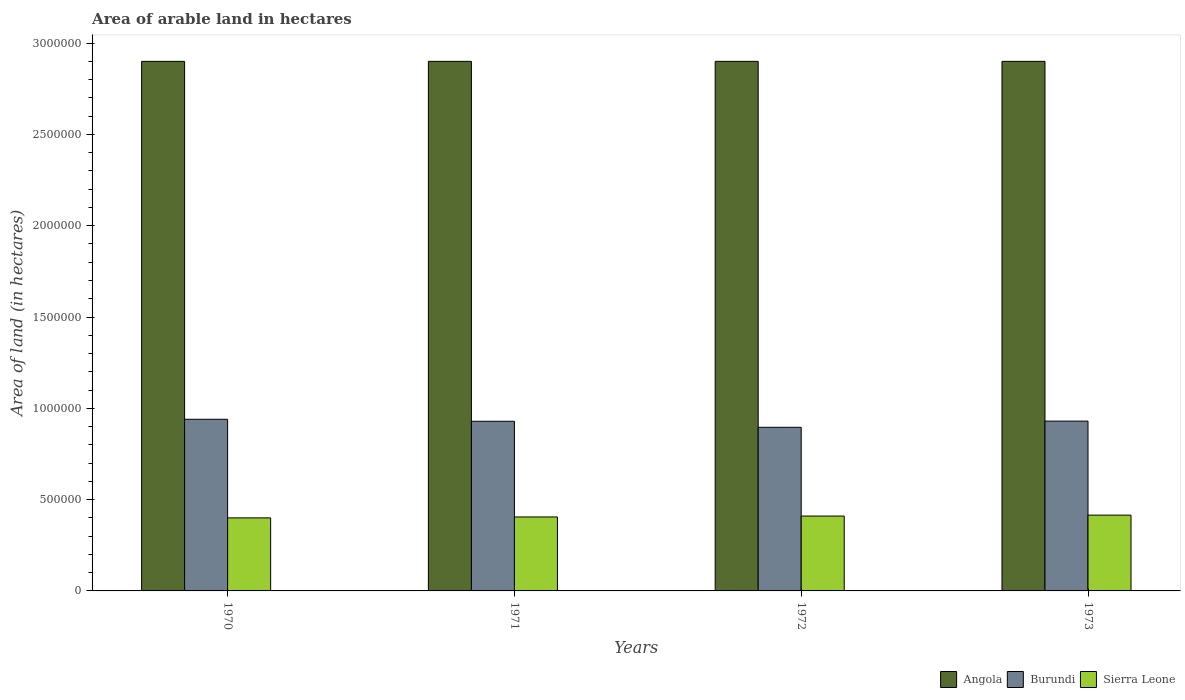How many different coloured bars are there?
Your response must be concise. 3. How many groups of bars are there?
Your answer should be very brief. 4. Are the number of bars per tick equal to the number of legend labels?
Make the answer very short. Yes. How many bars are there on the 3rd tick from the right?
Provide a succinct answer. 3. In how many cases, is the number of bars for a given year not equal to the number of legend labels?
Ensure brevity in your answer.  0. What is the total arable land in Sierra Leone in 1973?
Keep it short and to the point. 4.15e+05. Across all years, what is the maximum total arable land in Angola?
Offer a terse response. 2.90e+06. Across all years, what is the minimum total arable land in Angola?
Ensure brevity in your answer.  2.90e+06. In which year was the total arable land in Burundi maximum?
Provide a succinct answer. 1970. In which year was the total arable land in Angola minimum?
Offer a terse response. 1970. What is the total total arable land in Angola in the graph?
Ensure brevity in your answer.  1.16e+07. What is the difference between the total arable land in Angola in 1972 and that in 1973?
Provide a short and direct response. 0. What is the difference between the total arable land in Angola in 1970 and the total arable land in Burundi in 1972?
Your answer should be compact. 2.00e+06. What is the average total arable land in Angola per year?
Keep it short and to the point. 2.90e+06. In the year 1971, what is the difference between the total arable land in Burundi and total arable land in Angola?
Ensure brevity in your answer.  -1.97e+06. In how many years, is the total arable land in Burundi greater than 2200000 hectares?
Make the answer very short. 0. Is the total arable land in Burundi in 1971 less than that in 1973?
Offer a very short reply. Yes. What is the difference between the highest and the second highest total arable land in Angola?
Offer a terse response. 0. What is the difference between the highest and the lowest total arable land in Sierra Leone?
Keep it short and to the point. 1.50e+04. In how many years, is the total arable land in Burundi greater than the average total arable land in Burundi taken over all years?
Your answer should be very brief. 3. What does the 3rd bar from the left in 1972 represents?
Ensure brevity in your answer.  Sierra Leone. What does the 2nd bar from the right in 1970 represents?
Keep it short and to the point. Burundi. What is the difference between two consecutive major ticks on the Y-axis?
Make the answer very short. 5.00e+05. Where does the legend appear in the graph?
Your answer should be very brief. Bottom right. How many legend labels are there?
Your response must be concise. 3. How are the legend labels stacked?
Offer a terse response. Horizontal. What is the title of the graph?
Make the answer very short. Area of arable land in hectares. Does "Other small states" appear as one of the legend labels in the graph?
Keep it short and to the point. No. What is the label or title of the Y-axis?
Provide a succinct answer. Area of land (in hectares). What is the Area of land (in hectares) of Angola in 1970?
Ensure brevity in your answer.  2.90e+06. What is the Area of land (in hectares) of Burundi in 1970?
Keep it short and to the point. 9.40e+05. What is the Area of land (in hectares) of Angola in 1971?
Give a very brief answer. 2.90e+06. What is the Area of land (in hectares) in Burundi in 1971?
Keep it short and to the point. 9.29e+05. What is the Area of land (in hectares) of Sierra Leone in 1971?
Offer a very short reply. 4.05e+05. What is the Area of land (in hectares) in Angola in 1972?
Give a very brief answer. 2.90e+06. What is the Area of land (in hectares) in Burundi in 1972?
Your answer should be very brief. 8.96e+05. What is the Area of land (in hectares) of Sierra Leone in 1972?
Offer a terse response. 4.10e+05. What is the Area of land (in hectares) in Angola in 1973?
Offer a terse response. 2.90e+06. What is the Area of land (in hectares) of Burundi in 1973?
Your answer should be very brief. 9.30e+05. What is the Area of land (in hectares) of Sierra Leone in 1973?
Your answer should be very brief. 4.15e+05. Across all years, what is the maximum Area of land (in hectares) of Angola?
Ensure brevity in your answer.  2.90e+06. Across all years, what is the maximum Area of land (in hectares) of Burundi?
Provide a short and direct response. 9.40e+05. Across all years, what is the maximum Area of land (in hectares) of Sierra Leone?
Ensure brevity in your answer.  4.15e+05. Across all years, what is the minimum Area of land (in hectares) in Angola?
Provide a short and direct response. 2.90e+06. Across all years, what is the minimum Area of land (in hectares) of Burundi?
Ensure brevity in your answer.  8.96e+05. Across all years, what is the minimum Area of land (in hectares) in Sierra Leone?
Your answer should be compact. 4.00e+05. What is the total Area of land (in hectares) in Angola in the graph?
Give a very brief answer. 1.16e+07. What is the total Area of land (in hectares) in Burundi in the graph?
Ensure brevity in your answer.  3.70e+06. What is the total Area of land (in hectares) of Sierra Leone in the graph?
Provide a succinct answer. 1.63e+06. What is the difference between the Area of land (in hectares) of Angola in 1970 and that in 1971?
Your answer should be compact. 0. What is the difference between the Area of land (in hectares) of Burundi in 1970 and that in 1971?
Provide a short and direct response. 1.10e+04. What is the difference between the Area of land (in hectares) in Sierra Leone in 1970 and that in 1971?
Keep it short and to the point. -5000. What is the difference between the Area of land (in hectares) in Burundi in 1970 and that in 1972?
Ensure brevity in your answer.  4.40e+04. What is the difference between the Area of land (in hectares) of Angola in 1970 and that in 1973?
Ensure brevity in your answer.  0. What is the difference between the Area of land (in hectares) of Sierra Leone in 1970 and that in 1973?
Provide a short and direct response. -1.50e+04. What is the difference between the Area of land (in hectares) in Angola in 1971 and that in 1972?
Keep it short and to the point. 0. What is the difference between the Area of land (in hectares) of Burundi in 1971 and that in 1972?
Keep it short and to the point. 3.30e+04. What is the difference between the Area of land (in hectares) in Sierra Leone in 1971 and that in 1972?
Make the answer very short. -5000. What is the difference between the Area of land (in hectares) in Burundi in 1971 and that in 1973?
Provide a short and direct response. -1000. What is the difference between the Area of land (in hectares) of Sierra Leone in 1971 and that in 1973?
Offer a very short reply. -10000. What is the difference between the Area of land (in hectares) in Angola in 1972 and that in 1973?
Offer a terse response. 0. What is the difference between the Area of land (in hectares) of Burundi in 1972 and that in 1973?
Your answer should be very brief. -3.40e+04. What is the difference between the Area of land (in hectares) in Sierra Leone in 1972 and that in 1973?
Offer a very short reply. -5000. What is the difference between the Area of land (in hectares) in Angola in 1970 and the Area of land (in hectares) in Burundi in 1971?
Ensure brevity in your answer.  1.97e+06. What is the difference between the Area of land (in hectares) of Angola in 1970 and the Area of land (in hectares) of Sierra Leone in 1971?
Ensure brevity in your answer.  2.50e+06. What is the difference between the Area of land (in hectares) in Burundi in 1970 and the Area of land (in hectares) in Sierra Leone in 1971?
Offer a terse response. 5.35e+05. What is the difference between the Area of land (in hectares) in Angola in 1970 and the Area of land (in hectares) in Burundi in 1972?
Make the answer very short. 2.00e+06. What is the difference between the Area of land (in hectares) of Angola in 1970 and the Area of land (in hectares) of Sierra Leone in 1972?
Give a very brief answer. 2.49e+06. What is the difference between the Area of land (in hectares) in Burundi in 1970 and the Area of land (in hectares) in Sierra Leone in 1972?
Keep it short and to the point. 5.30e+05. What is the difference between the Area of land (in hectares) of Angola in 1970 and the Area of land (in hectares) of Burundi in 1973?
Offer a terse response. 1.97e+06. What is the difference between the Area of land (in hectares) in Angola in 1970 and the Area of land (in hectares) in Sierra Leone in 1973?
Your answer should be compact. 2.48e+06. What is the difference between the Area of land (in hectares) of Burundi in 1970 and the Area of land (in hectares) of Sierra Leone in 1973?
Provide a short and direct response. 5.25e+05. What is the difference between the Area of land (in hectares) in Angola in 1971 and the Area of land (in hectares) in Burundi in 1972?
Make the answer very short. 2.00e+06. What is the difference between the Area of land (in hectares) of Angola in 1971 and the Area of land (in hectares) of Sierra Leone in 1972?
Give a very brief answer. 2.49e+06. What is the difference between the Area of land (in hectares) in Burundi in 1971 and the Area of land (in hectares) in Sierra Leone in 1972?
Your answer should be very brief. 5.19e+05. What is the difference between the Area of land (in hectares) in Angola in 1971 and the Area of land (in hectares) in Burundi in 1973?
Ensure brevity in your answer.  1.97e+06. What is the difference between the Area of land (in hectares) in Angola in 1971 and the Area of land (in hectares) in Sierra Leone in 1973?
Make the answer very short. 2.48e+06. What is the difference between the Area of land (in hectares) in Burundi in 1971 and the Area of land (in hectares) in Sierra Leone in 1973?
Offer a very short reply. 5.14e+05. What is the difference between the Area of land (in hectares) of Angola in 1972 and the Area of land (in hectares) of Burundi in 1973?
Provide a short and direct response. 1.97e+06. What is the difference between the Area of land (in hectares) in Angola in 1972 and the Area of land (in hectares) in Sierra Leone in 1973?
Offer a very short reply. 2.48e+06. What is the difference between the Area of land (in hectares) in Burundi in 1972 and the Area of land (in hectares) in Sierra Leone in 1973?
Offer a terse response. 4.81e+05. What is the average Area of land (in hectares) of Angola per year?
Offer a very short reply. 2.90e+06. What is the average Area of land (in hectares) of Burundi per year?
Your response must be concise. 9.24e+05. What is the average Area of land (in hectares) of Sierra Leone per year?
Keep it short and to the point. 4.08e+05. In the year 1970, what is the difference between the Area of land (in hectares) in Angola and Area of land (in hectares) in Burundi?
Ensure brevity in your answer.  1.96e+06. In the year 1970, what is the difference between the Area of land (in hectares) of Angola and Area of land (in hectares) of Sierra Leone?
Your answer should be compact. 2.50e+06. In the year 1970, what is the difference between the Area of land (in hectares) of Burundi and Area of land (in hectares) of Sierra Leone?
Give a very brief answer. 5.40e+05. In the year 1971, what is the difference between the Area of land (in hectares) of Angola and Area of land (in hectares) of Burundi?
Your answer should be compact. 1.97e+06. In the year 1971, what is the difference between the Area of land (in hectares) in Angola and Area of land (in hectares) in Sierra Leone?
Provide a short and direct response. 2.50e+06. In the year 1971, what is the difference between the Area of land (in hectares) in Burundi and Area of land (in hectares) in Sierra Leone?
Keep it short and to the point. 5.24e+05. In the year 1972, what is the difference between the Area of land (in hectares) in Angola and Area of land (in hectares) in Burundi?
Provide a short and direct response. 2.00e+06. In the year 1972, what is the difference between the Area of land (in hectares) of Angola and Area of land (in hectares) of Sierra Leone?
Keep it short and to the point. 2.49e+06. In the year 1972, what is the difference between the Area of land (in hectares) of Burundi and Area of land (in hectares) of Sierra Leone?
Ensure brevity in your answer.  4.86e+05. In the year 1973, what is the difference between the Area of land (in hectares) of Angola and Area of land (in hectares) of Burundi?
Provide a succinct answer. 1.97e+06. In the year 1973, what is the difference between the Area of land (in hectares) in Angola and Area of land (in hectares) in Sierra Leone?
Offer a very short reply. 2.48e+06. In the year 1973, what is the difference between the Area of land (in hectares) in Burundi and Area of land (in hectares) in Sierra Leone?
Provide a short and direct response. 5.15e+05. What is the ratio of the Area of land (in hectares) of Burundi in 1970 to that in 1971?
Your answer should be compact. 1.01. What is the ratio of the Area of land (in hectares) of Angola in 1970 to that in 1972?
Offer a very short reply. 1. What is the ratio of the Area of land (in hectares) of Burundi in 1970 to that in 1972?
Your response must be concise. 1.05. What is the ratio of the Area of land (in hectares) of Sierra Leone in 1970 to that in 1972?
Make the answer very short. 0.98. What is the ratio of the Area of land (in hectares) of Burundi in 1970 to that in 1973?
Your response must be concise. 1.01. What is the ratio of the Area of land (in hectares) of Sierra Leone in 1970 to that in 1973?
Provide a succinct answer. 0.96. What is the ratio of the Area of land (in hectares) of Burundi in 1971 to that in 1972?
Ensure brevity in your answer.  1.04. What is the ratio of the Area of land (in hectares) in Angola in 1971 to that in 1973?
Your response must be concise. 1. What is the ratio of the Area of land (in hectares) in Sierra Leone in 1971 to that in 1973?
Your answer should be compact. 0.98. What is the ratio of the Area of land (in hectares) in Burundi in 1972 to that in 1973?
Offer a terse response. 0.96. What is the difference between the highest and the lowest Area of land (in hectares) of Burundi?
Your answer should be very brief. 4.40e+04. What is the difference between the highest and the lowest Area of land (in hectares) in Sierra Leone?
Your answer should be very brief. 1.50e+04. 